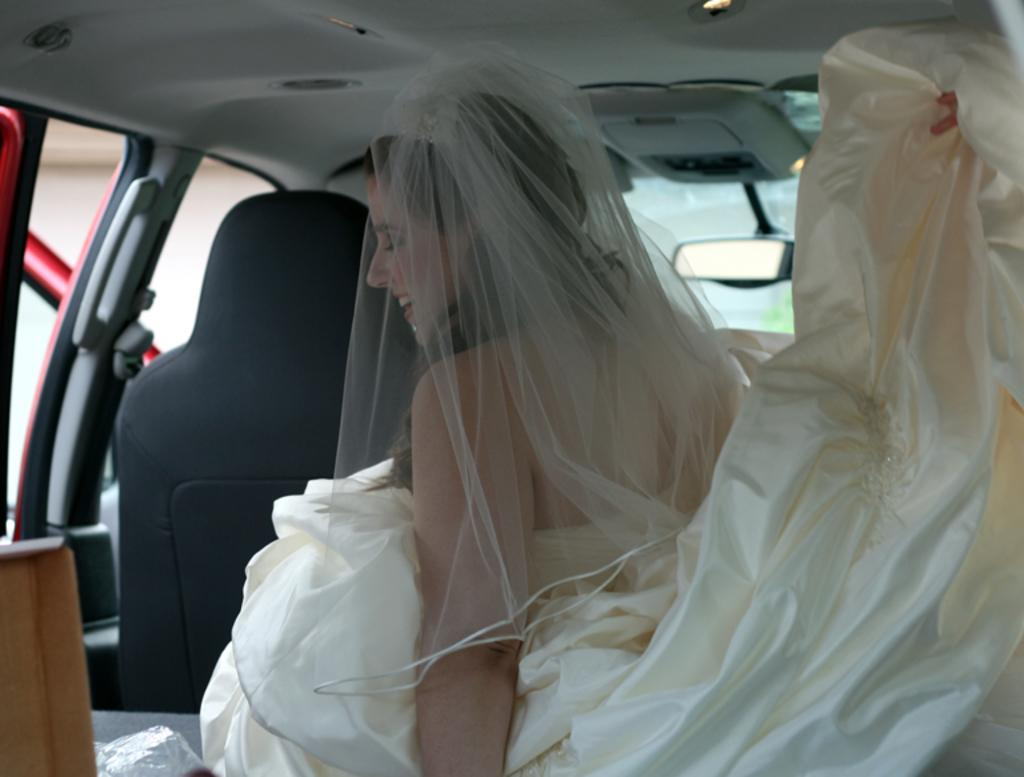Who is the main subject in the image? There is a woman in the image. What is the woman doing in the image? The woman is sitting in a car. What is the woman wearing in the image? The woman is wearing a wedding gown. What is on the woman's head in the image? There is a netted cloth on the woman's head. What is the woman's facial expression in the image? The woman is smiling. What type of goldfish is swimming in the woman's mind in the image? There is no goldfish present in the image, and the woman's mind cannot be seen. 